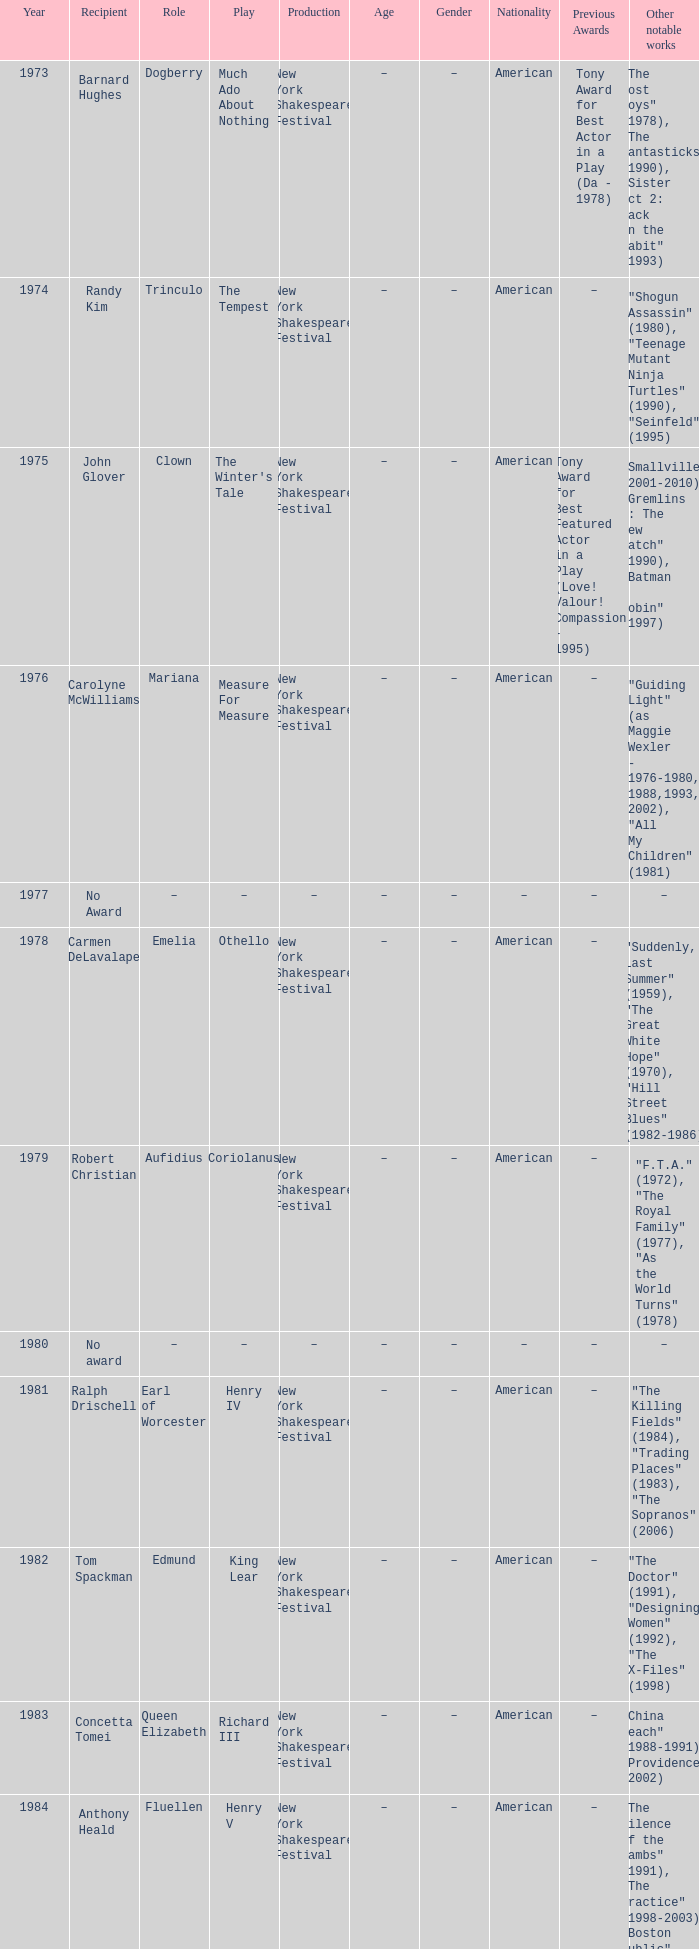Name the average year for much ado about nothing and recipient of ray virta 2002.0. 